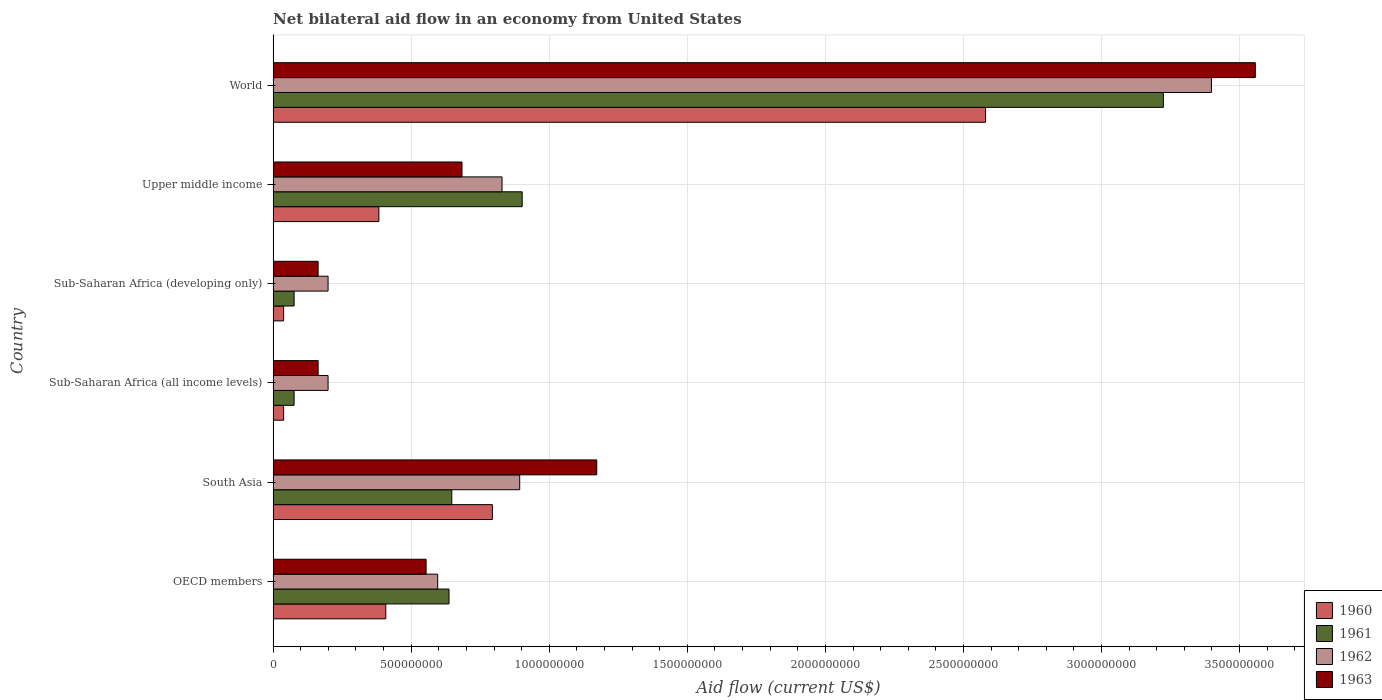How many different coloured bars are there?
Your answer should be compact. 4. How many groups of bars are there?
Provide a succinct answer. 6. Are the number of bars per tick equal to the number of legend labels?
Make the answer very short. Yes. How many bars are there on the 5th tick from the top?
Keep it short and to the point. 4. What is the label of the 5th group of bars from the top?
Your answer should be very brief. South Asia. In how many cases, is the number of bars for a given country not equal to the number of legend labels?
Give a very brief answer. 0. What is the net bilateral aid flow in 1961 in South Asia?
Your response must be concise. 6.47e+08. Across all countries, what is the maximum net bilateral aid flow in 1961?
Give a very brief answer. 3.22e+09. Across all countries, what is the minimum net bilateral aid flow in 1960?
Ensure brevity in your answer.  3.80e+07. In which country was the net bilateral aid flow in 1960 maximum?
Your answer should be very brief. World. In which country was the net bilateral aid flow in 1961 minimum?
Provide a short and direct response. Sub-Saharan Africa (all income levels). What is the total net bilateral aid flow in 1960 in the graph?
Give a very brief answer. 4.24e+09. What is the difference between the net bilateral aid flow in 1960 in OECD members and that in Upper middle income?
Your answer should be compact. 2.50e+07. What is the difference between the net bilateral aid flow in 1961 in World and the net bilateral aid flow in 1960 in Upper middle income?
Your response must be concise. 2.84e+09. What is the average net bilateral aid flow in 1963 per country?
Offer a very short reply. 1.05e+09. What is the difference between the net bilateral aid flow in 1962 and net bilateral aid flow in 1960 in Sub-Saharan Africa (developing only)?
Give a very brief answer. 1.61e+08. In how many countries, is the net bilateral aid flow in 1962 greater than 1500000000 US$?
Offer a terse response. 1. What is the ratio of the net bilateral aid flow in 1961 in South Asia to that in Sub-Saharan Africa (all income levels)?
Provide a short and direct response. 8.51. Is the net bilateral aid flow in 1961 in South Asia less than that in Sub-Saharan Africa (all income levels)?
Offer a very short reply. No. Is the difference between the net bilateral aid flow in 1962 in South Asia and Upper middle income greater than the difference between the net bilateral aid flow in 1960 in South Asia and Upper middle income?
Make the answer very short. No. What is the difference between the highest and the second highest net bilateral aid flow in 1962?
Ensure brevity in your answer.  2.50e+09. What is the difference between the highest and the lowest net bilateral aid flow in 1960?
Make the answer very short. 2.54e+09. In how many countries, is the net bilateral aid flow in 1962 greater than the average net bilateral aid flow in 1962 taken over all countries?
Give a very brief answer. 1. Is the sum of the net bilateral aid flow in 1960 in South Asia and Sub-Saharan Africa (developing only) greater than the maximum net bilateral aid flow in 1962 across all countries?
Offer a very short reply. No. Is it the case that in every country, the sum of the net bilateral aid flow in 1963 and net bilateral aid flow in 1962 is greater than the net bilateral aid flow in 1961?
Provide a succinct answer. Yes. How many bars are there?
Your answer should be very brief. 24. Are all the bars in the graph horizontal?
Your response must be concise. Yes. Are the values on the major ticks of X-axis written in scientific E-notation?
Provide a short and direct response. No. Where does the legend appear in the graph?
Provide a short and direct response. Bottom right. How many legend labels are there?
Keep it short and to the point. 4. How are the legend labels stacked?
Give a very brief answer. Vertical. What is the title of the graph?
Ensure brevity in your answer.  Net bilateral aid flow in an economy from United States. Does "1996" appear as one of the legend labels in the graph?
Make the answer very short. No. What is the label or title of the Y-axis?
Make the answer very short. Country. What is the Aid flow (current US$) of 1960 in OECD members?
Your response must be concise. 4.08e+08. What is the Aid flow (current US$) of 1961 in OECD members?
Provide a short and direct response. 6.37e+08. What is the Aid flow (current US$) in 1962 in OECD members?
Offer a very short reply. 5.96e+08. What is the Aid flow (current US$) of 1963 in OECD members?
Ensure brevity in your answer.  5.54e+08. What is the Aid flow (current US$) in 1960 in South Asia?
Give a very brief answer. 7.94e+08. What is the Aid flow (current US$) in 1961 in South Asia?
Your answer should be very brief. 6.47e+08. What is the Aid flow (current US$) in 1962 in South Asia?
Give a very brief answer. 8.93e+08. What is the Aid flow (current US$) in 1963 in South Asia?
Provide a succinct answer. 1.17e+09. What is the Aid flow (current US$) in 1960 in Sub-Saharan Africa (all income levels)?
Give a very brief answer. 3.80e+07. What is the Aid flow (current US$) in 1961 in Sub-Saharan Africa (all income levels)?
Offer a very short reply. 7.60e+07. What is the Aid flow (current US$) of 1962 in Sub-Saharan Africa (all income levels)?
Your answer should be compact. 1.99e+08. What is the Aid flow (current US$) of 1963 in Sub-Saharan Africa (all income levels)?
Give a very brief answer. 1.63e+08. What is the Aid flow (current US$) in 1960 in Sub-Saharan Africa (developing only)?
Provide a succinct answer. 3.80e+07. What is the Aid flow (current US$) of 1961 in Sub-Saharan Africa (developing only)?
Make the answer very short. 7.60e+07. What is the Aid flow (current US$) of 1962 in Sub-Saharan Africa (developing only)?
Offer a terse response. 1.99e+08. What is the Aid flow (current US$) in 1963 in Sub-Saharan Africa (developing only)?
Make the answer very short. 1.63e+08. What is the Aid flow (current US$) in 1960 in Upper middle income?
Keep it short and to the point. 3.83e+08. What is the Aid flow (current US$) in 1961 in Upper middle income?
Your response must be concise. 9.02e+08. What is the Aid flow (current US$) in 1962 in Upper middle income?
Your answer should be compact. 8.29e+08. What is the Aid flow (current US$) in 1963 in Upper middle income?
Your response must be concise. 6.84e+08. What is the Aid flow (current US$) in 1960 in World?
Ensure brevity in your answer.  2.58e+09. What is the Aid flow (current US$) of 1961 in World?
Make the answer very short. 3.22e+09. What is the Aid flow (current US$) of 1962 in World?
Your answer should be compact. 3.40e+09. What is the Aid flow (current US$) of 1963 in World?
Your answer should be compact. 3.56e+09. Across all countries, what is the maximum Aid flow (current US$) in 1960?
Keep it short and to the point. 2.58e+09. Across all countries, what is the maximum Aid flow (current US$) of 1961?
Provide a short and direct response. 3.22e+09. Across all countries, what is the maximum Aid flow (current US$) of 1962?
Ensure brevity in your answer.  3.40e+09. Across all countries, what is the maximum Aid flow (current US$) in 1963?
Your answer should be compact. 3.56e+09. Across all countries, what is the minimum Aid flow (current US$) of 1960?
Provide a short and direct response. 3.80e+07. Across all countries, what is the minimum Aid flow (current US$) of 1961?
Keep it short and to the point. 7.60e+07. Across all countries, what is the minimum Aid flow (current US$) in 1962?
Your answer should be compact. 1.99e+08. Across all countries, what is the minimum Aid flow (current US$) in 1963?
Offer a terse response. 1.63e+08. What is the total Aid flow (current US$) in 1960 in the graph?
Offer a terse response. 4.24e+09. What is the total Aid flow (current US$) in 1961 in the graph?
Offer a terse response. 5.56e+09. What is the total Aid flow (current US$) of 1962 in the graph?
Give a very brief answer. 6.11e+09. What is the total Aid flow (current US$) of 1963 in the graph?
Provide a short and direct response. 6.29e+09. What is the difference between the Aid flow (current US$) of 1960 in OECD members and that in South Asia?
Ensure brevity in your answer.  -3.86e+08. What is the difference between the Aid flow (current US$) of 1961 in OECD members and that in South Asia?
Offer a terse response. -1.00e+07. What is the difference between the Aid flow (current US$) in 1962 in OECD members and that in South Asia?
Offer a terse response. -2.97e+08. What is the difference between the Aid flow (current US$) of 1963 in OECD members and that in South Asia?
Keep it short and to the point. -6.18e+08. What is the difference between the Aid flow (current US$) in 1960 in OECD members and that in Sub-Saharan Africa (all income levels)?
Make the answer very short. 3.70e+08. What is the difference between the Aid flow (current US$) in 1961 in OECD members and that in Sub-Saharan Africa (all income levels)?
Ensure brevity in your answer.  5.61e+08. What is the difference between the Aid flow (current US$) in 1962 in OECD members and that in Sub-Saharan Africa (all income levels)?
Ensure brevity in your answer.  3.97e+08. What is the difference between the Aid flow (current US$) in 1963 in OECD members and that in Sub-Saharan Africa (all income levels)?
Your answer should be compact. 3.91e+08. What is the difference between the Aid flow (current US$) in 1960 in OECD members and that in Sub-Saharan Africa (developing only)?
Your response must be concise. 3.70e+08. What is the difference between the Aid flow (current US$) of 1961 in OECD members and that in Sub-Saharan Africa (developing only)?
Your answer should be very brief. 5.61e+08. What is the difference between the Aid flow (current US$) of 1962 in OECD members and that in Sub-Saharan Africa (developing only)?
Offer a very short reply. 3.97e+08. What is the difference between the Aid flow (current US$) of 1963 in OECD members and that in Sub-Saharan Africa (developing only)?
Make the answer very short. 3.91e+08. What is the difference between the Aid flow (current US$) in 1960 in OECD members and that in Upper middle income?
Your response must be concise. 2.50e+07. What is the difference between the Aid flow (current US$) of 1961 in OECD members and that in Upper middle income?
Your answer should be very brief. -2.65e+08. What is the difference between the Aid flow (current US$) of 1962 in OECD members and that in Upper middle income?
Your response must be concise. -2.33e+08. What is the difference between the Aid flow (current US$) of 1963 in OECD members and that in Upper middle income?
Your response must be concise. -1.30e+08. What is the difference between the Aid flow (current US$) of 1960 in OECD members and that in World?
Make the answer very short. -2.17e+09. What is the difference between the Aid flow (current US$) of 1961 in OECD members and that in World?
Keep it short and to the point. -2.59e+09. What is the difference between the Aid flow (current US$) of 1962 in OECD members and that in World?
Provide a short and direct response. -2.80e+09. What is the difference between the Aid flow (current US$) of 1963 in OECD members and that in World?
Keep it short and to the point. -3.00e+09. What is the difference between the Aid flow (current US$) in 1960 in South Asia and that in Sub-Saharan Africa (all income levels)?
Provide a short and direct response. 7.56e+08. What is the difference between the Aid flow (current US$) in 1961 in South Asia and that in Sub-Saharan Africa (all income levels)?
Make the answer very short. 5.71e+08. What is the difference between the Aid flow (current US$) in 1962 in South Asia and that in Sub-Saharan Africa (all income levels)?
Give a very brief answer. 6.94e+08. What is the difference between the Aid flow (current US$) in 1963 in South Asia and that in Sub-Saharan Africa (all income levels)?
Your response must be concise. 1.01e+09. What is the difference between the Aid flow (current US$) in 1960 in South Asia and that in Sub-Saharan Africa (developing only)?
Your response must be concise. 7.56e+08. What is the difference between the Aid flow (current US$) of 1961 in South Asia and that in Sub-Saharan Africa (developing only)?
Your answer should be compact. 5.71e+08. What is the difference between the Aid flow (current US$) in 1962 in South Asia and that in Sub-Saharan Africa (developing only)?
Give a very brief answer. 6.94e+08. What is the difference between the Aid flow (current US$) of 1963 in South Asia and that in Sub-Saharan Africa (developing only)?
Your response must be concise. 1.01e+09. What is the difference between the Aid flow (current US$) in 1960 in South Asia and that in Upper middle income?
Make the answer very short. 4.11e+08. What is the difference between the Aid flow (current US$) in 1961 in South Asia and that in Upper middle income?
Provide a succinct answer. -2.55e+08. What is the difference between the Aid flow (current US$) of 1962 in South Asia and that in Upper middle income?
Your answer should be very brief. 6.40e+07. What is the difference between the Aid flow (current US$) of 1963 in South Asia and that in Upper middle income?
Provide a succinct answer. 4.88e+08. What is the difference between the Aid flow (current US$) in 1960 in South Asia and that in World?
Your answer should be very brief. -1.79e+09. What is the difference between the Aid flow (current US$) in 1961 in South Asia and that in World?
Your answer should be very brief. -2.58e+09. What is the difference between the Aid flow (current US$) of 1962 in South Asia and that in World?
Ensure brevity in your answer.  -2.50e+09. What is the difference between the Aid flow (current US$) of 1963 in South Asia and that in World?
Your answer should be very brief. -2.38e+09. What is the difference between the Aid flow (current US$) in 1960 in Sub-Saharan Africa (all income levels) and that in Sub-Saharan Africa (developing only)?
Your answer should be compact. 0. What is the difference between the Aid flow (current US$) of 1962 in Sub-Saharan Africa (all income levels) and that in Sub-Saharan Africa (developing only)?
Provide a short and direct response. 0. What is the difference between the Aid flow (current US$) of 1960 in Sub-Saharan Africa (all income levels) and that in Upper middle income?
Make the answer very short. -3.45e+08. What is the difference between the Aid flow (current US$) in 1961 in Sub-Saharan Africa (all income levels) and that in Upper middle income?
Make the answer very short. -8.26e+08. What is the difference between the Aid flow (current US$) in 1962 in Sub-Saharan Africa (all income levels) and that in Upper middle income?
Your answer should be compact. -6.30e+08. What is the difference between the Aid flow (current US$) in 1963 in Sub-Saharan Africa (all income levels) and that in Upper middle income?
Your answer should be very brief. -5.21e+08. What is the difference between the Aid flow (current US$) of 1960 in Sub-Saharan Africa (all income levels) and that in World?
Give a very brief answer. -2.54e+09. What is the difference between the Aid flow (current US$) in 1961 in Sub-Saharan Africa (all income levels) and that in World?
Give a very brief answer. -3.15e+09. What is the difference between the Aid flow (current US$) in 1962 in Sub-Saharan Africa (all income levels) and that in World?
Keep it short and to the point. -3.20e+09. What is the difference between the Aid flow (current US$) in 1963 in Sub-Saharan Africa (all income levels) and that in World?
Offer a terse response. -3.39e+09. What is the difference between the Aid flow (current US$) of 1960 in Sub-Saharan Africa (developing only) and that in Upper middle income?
Ensure brevity in your answer.  -3.45e+08. What is the difference between the Aid flow (current US$) in 1961 in Sub-Saharan Africa (developing only) and that in Upper middle income?
Your answer should be very brief. -8.26e+08. What is the difference between the Aid flow (current US$) of 1962 in Sub-Saharan Africa (developing only) and that in Upper middle income?
Your response must be concise. -6.30e+08. What is the difference between the Aid flow (current US$) in 1963 in Sub-Saharan Africa (developing only) and that in Upper middle income?
Offer a very short reply. -5.21e+08. What is the difference between the Aid flow (current US$) of 1960 in Sub-Saharan Africa (developing only) and that in World?
Keep it short and to the point. -2.54e+09. What is the difference between the Aid flow (current US$) in 1961 in Sub-Saharan Africa (developing only) and that in World?
Offer a very short reply. -3.15e+09. What is the difference between the Aid flow (current US$) in 1962 in Sub-Saharan Africa (developing only) and that in World?
Ensure brevity in your answer.  -3.20e+09. What is the difference between the Aid flow (current US$) in 1963 in Sub-Saharan Africa (developing only) and that in World?
Give a very brief answer. -3.39e+09. What is the difference between the Aid flow (current US$) of 1960 in Upper middle income and that in World?
Offer a very short reply. -2.20e+09. What is the difference between the Aid flow (current US$) of 1961 in Upper middle income and that in World?
Make the answer very short. -2.32e+09. What is the difference between the Aid flow (current US$) in 1962 in Upper middle income and that in World?
Provide a succinct answer. -2.57e+09. What is the difference between the Aid flow (current US$) of 1963 in Upper middle income and that in World?
Your answer should be very brief. -2.87e+09. What is the difference between the Aid flow (current US$) of 1960 in OECD members and the Aid flow (current US$) of 1961 in South Asia?
Offer a terse response. -2.39e+08. What is the difference between the Aid flow (current US$) in 1960 in OECD members and the Aid flow (current US$) in 1962 in South Asia?
Give a very brief answer. -4.85e+08. What is the difference between the Aid flow (current US$) of 1960 in OECD members and the Aid flow (current US$) of 1963 in South Asia?
Keep it short and to the point. -7.64e+08. What is the difference between the Aid flow (current US$) in 1961 in OECD members and the Aid flow (current US$) in 1962 in South Asia?
Your answer should be compact. -2.56e+08. What is the difference between the Aid flow (current US$) in 1961 in OECD members and the Aid flow (current US$) in 1963 in South Asia?
Your response must be concise. -5.35e+08. What is the difference between the Aid flow (current US$) in 1962 in OECD members and the Aid flow (current US$) in 1963 in South Asia?
Provide a succinct answer. -5.76e+08. What is the difference between the Aid flow (current US$) in 1960 in OECD members and the Aid flow (current US$) in 1961 in Sub-Saharan Africa (all income levels)?
Make the answer very short. 3.32e+08. What is the difference between the Aid flow (current US$) in 1960 in OECD members and the Aid flow (current US$) in 1962 in Sub-Saharan Africa (all income levels)?
Your answer should be very brief. 2.09e+08. What is the difference between the Aid flow (current US$) in 1960 in OECD members and the Aid flow (current US$) in 1963 in Sub-Saharan Africa (all income levels)?
Your answer should be very brief. 2.45e+08. What is the difference between the Aid flow (current US$) of 1961 in OECD members and the Aid flow (current US$) of 1962 in Sub-Saharan Africa (all income levels)?
Offer a terse response. 4.38e+08. What is the difference between the Aid flow (current US$) of 1961 in OECD members and the Aid flow (current US$) of 1963 in Sub-Saharan Africa (all income levels)?
Make the answer very short. 4.74e+08. What is the difference between the Aid flow (current US$) of 1962 in OECD members and the Aid flow (current US$) of 1963 in Sub-Saharan Africa (all income levels)?
Your answer should be very brief. 4.33e+08. What is the difference between the Aid flow (current US$) in 1960 in OECD members and the Aid flow (current US$) in 1961 in Sub-Saharan Africa (developing only)?
Your answer should be very brief. 3.32e+08. What is the difference between the Aid flow (current US$) of 1960 in OECD members and the Aid flow (current US$) of 1962 in Sub-Saharan Africa (developing only)?
Provide a short and direct response. 2.09e+08. What is the difference between the Aid flow (current US$) in 1960 in OECD members and the Aid flow (current US$) in 1963 in Sub-Saharan Africa (developing only)?
Offer a very short reply. 2.45e+08. What is the difference between the Aid flow (current US$) of 1961 in OECD members and the Aid flow (current US$) of 1962 in Sub-Saharan Africa (developing only)?
Give a very brief answer. 4.38e+08. What is the difference between the Aid flow (current US$) of 1961 in OECD members and the Aid flow (current US$) of 1963 in Sub-Saharan Africa (developing only)?
Your answer should be very brief. 4.74e+08. What is the difference between the Aid flow (current US$) in 1962 in OECD members and the Aid flow (current US$) in 1963 in Sub-Saharan Africa (developing only)?
Your answer should be compact. 4.33e+08. What is the difference between the Aid flow (current US$) in 1960 in OECD members and the Aid flow (current US$) in 1961 in Upper middle income?
Keep it short and to the point. -4.94e+08. What is the difference between the Aid flow (current US$) of 1960 in OECD members and the Aid flow (current US$) of 1962 in Upper middle income?
Your answer should be compact. -4.21e+08. What is the difference between the Aid flow (current US$) in 1960 in OECD members and the Aid flow (current US$) in 1963 in Upper middle income?
Offer a very short reply. -2.76e+08. What is the difference between the Aid flow (current US$) of 1961 in OECD members and the Aid flow (current US$) of 1962 in Upper middle income?
Offer a very short reply. -1.92e+08. What is the difference between the Aid flow (current US$) in 1961 in OECD members and the Aid flow (current US$) in 1963 in Upper middle income?
Keep it short and to the point. -4.70e+07. What is the difference between the Aid flow (current US$) in 1962 in OECD members and the Aid flow (current US$) in 1963 in Upper middle income?
Keep it short and to the point. -8.80e+07. What is the difference between the Aid flow (current US$) of 1960 in OECD members and the Aid flow (current US$) of 1961 in World?
Your response must be concise. -2.82e+09. What is the difference between the Aid flow (current US$) in 1960 in OECD members and the Aid flow (current US$) in 1962 in World?
Your answer should be very brief. -2.99e+09. What is the difference between the Aid flow (current US$) of 1960 in OECD members and the Aid flow (current US$) of 1963 in World?
Make the answer very short. -3.15e+09. What is the difference between the Aid flow (current US$) of 1961 in OECD members and the Aid flow (current US$) of 1962 in World?
Make the answer very short. -2.76e+09. What is the difference between the Aid flow (current US$) of 1961 in OECD members and the Aid flow (current US$) of 1963 in World?
Ensure brevity in your answer.  -2.92e+09. What is the difference between the Aid flow (current US$) in 1962 in OECD members and the Aid flow (current US$) in 1963 in World?
Offer a terse response. -2.96e+09. What is the difference between the Aid flow (current US$) of 1960 in South Asia and the Aid flow (current US$) of 1961 in Sub-Saharan Africa (all income levels)?
Make the answer very short. 7.18e+08. What is the difference between the Aid flow (current US$) of 1960 in South Asia and the Aid flow (current US$) of 1962 in Sub-Saharan Africa (all income levels)?
Offer a terse response. 5.95e+08. What is the difference between the Aid flow (current US$) in 1960 in South Asia and the Aid flow (current US$) in 1963 in Sub-Saharan Africa (all income levels)?
Provide a succinct answer. 6.31e+08. What is the difference between the Aid flow (current US$) in 1961 in South Asia and the Aid flow (current US$) in 1962 in Sub-Saharan Africa (all income levels)?
Give a very brief answer. 4.48e+08. What is the difference between the Aid flow (current US$) in 1961 in South Asia and the Aid flow (current US$) in 1963 in Sub-Saharan Africa (all income levels)?
Your answer should be compact. 4.84e+08. What is the difference between the Aid flow (current US$) of 1962 in South Asia and the Aid flow (current US$) of 1963 in Sub-Saharan Africa (all income levels)?
Ensure brevity in your answer.  7.30e+08. What is the difference between the Aid flow (current US$) of 1960 in South Asia and the Aid flow (current US$) of 1961 in Sub-Saharan Africa (developing only)?
Provide a succinct answer. 7.18e+08. What is the difference between the Aid flow (current US$) of 1960 in South Asia and the Aid flow (current US$) of 1962 in Sub-Saharan Africa (developing only)?
Ensure brevity in your answer.  5.95e+08. What is the difference between the Aid flow (current US$) of 1960 in South Asia and the Aid flow (current US$) of 1963 in Sub-Saharan Africa (developing only)?
Give a very brief answer. 6.31e+08. What is the difference between the Aid flow (current US$) of 1961 in South Asia and the Aid flow (current US$) of 1962 in Sub-Saharan Africa (developing only)?
Offer a terse response. 4.48e+08. What is the difference between the Aid flow (current US$) in 1961 in South Asia and the Aid flow (current US$) in 1963 in Sub-Saharan Africa (developing only)?
Give a very brief answer. 4.84e+08. What is the difference between the Aid flow (current US$) in 1962 in South Asia and the Aid flow (current US$) in 1963 in Sub-Saharan Africa (developing only)?
Provide a short and direct response. 7.30e+08. What is the difference between the Aid flow (current US$) in 1960 in South Asia and the Aid flow (current US$) in 1961 in Upper middle income?
Your response must be concise. -1.08e+08. What is the difference between the Aid flow (current US$) in 1960 in South Asia and the Aid flow (current US$) in 1962 in Upper middle income?
Your answer should be compact. -3.50e+07. What is the difference between the Aid flow (current US$) of 1960 in South Asia and the Aid flow (current US$) of 1963 in Upper middle income?
Your response must be concise. 1.10e+08. What is the difference between the Aid flow (current US$) of 1961 in South Asia and the Aid flow (current US$) of 1962 in Upper middle income?
Your response must be concise. -1.82e+08. What is the difference between the Aid flow (current US$) of 1961 in South Asia and the Aid flow (current US$) of 1963 in Upper middle income?
Offer a very short reply. -3.70e+07. What is the difference between the Aid flow (current US$) of 1962 in South Asia and the Aid flow (current US$) of 1963 in Upper middle income?
Keep it short and to the point. 2.09e+08. What is the difference between the Aid flow (current US$) in 1960 in South Asia and the Aid flow (current US$) in 1961 in World?
Provide a succinct answer. -2.43e+09. What is the difference between the Aid flow (current US$) in 1960 in South Asia and the Aid flow (current US$) in 1962 in World?
Your answer should be very brief. -2.60e+09. What is the difference between the Aid flow (current US$) of 1960 in South Asia and the Aid flow (current US$) of 1963 in World?
Offer a very short reply. -2.76e+09. What is the difference between the Aid flow (current US$) of 1961 in South Asia and the Aid flow (current US$) of 1962 in World?
Your response must be concise. -2.75e+09. What is the difference between the Aid flow (current US$) in 1961 in South Asia and the Aid flow (current US$) in 1963 in World?
Provide a short and direct response. -2.91e+09. What is the difference between the Aid flow (current US$) in 1962 in South Asia and the Aid flow (current US$) in 1963 in World?
Make the answer very short. -2.66e+09. What is the difference between the Aid flow (current US$) of 1960 in Sub-Saharan Africa (all income levels) and the Aid flow (current US$) of 1961 in Sub-Saharan Africa (developing only)?
Offer a terse response. -3.80e+07. What is the difference between the Aid flow (current US$) of 1960 in Sub-Saharan Africa (all income levels) and the Aid flow (current US$) of 1962 in Sub-Saharan Africa (developing only)?
Offer a terse response. -1.61e+08. What is the difference between the Aid flow (current US$) in 1960 in Sub-Saharan Africa (all income levels) and the Aid flow (current US$) in 1963 in Sub-Saharan Africa (developing only)?
Your answer should be very brief. -1.25e+08. What is the difference between the Aid flow (current US$) in 1961 in Sub-Saharan Africa (all income levels) and the Aid flow (current US$) in 1962 in Sub-Saharan Africa (developing only)?
Give a very brief answer. -1.23e+08. What is the difference between the Aid flow (current US$) in 1961 in Sub-Saharan Africa (all income levels) and the Aid flow (current US$) in 1963 in Sub-Saharan Africa (developing only)?
Provide a succinct answer. -8.70e+07. What is the difference between the Aid flow (current US$) in 1962 in Sub-Saharan Africa (all income levels) and the Aid flow (current US$) in 1963 in Sub-Saharan Africa (developing only)?
Offer a terse response. 3.60e+07. What is the difference between the Aid flow (current US$) of 1960 in Sub-Saharan Africa (all income levels) and the Aid flow (current US$) of 1961 in Upper middle income?
Ensure brevity in your answer.  -8.64e+08. What is the difference between the Aid flow (current US$) in 1960 in Sub-Saharan Africa (all income levels) and the Aid flow (current US$) in 1962 in Upper middle income?
Give a very brief answer. -7.91e+08. What is the difference between the Aid flow (current US$) of 1960 in Sub-Saharan Africa (all income levels) and the Aid flow (current US$) of 1963 in Upper middle income?
Ensure brevity in your answer.  -6.46e+08. What is the difference between the Aid flow (current US$) of 1961 in Sub-Saharan Africa (all income levels) and the Aid flow (current US$) of 1962 in Upper middle income?
Your response must be concise. -7.53e+08. What is the difference between the Aid flow (current US$) in 1961 in Sub-Saharan Africa (all income levels) and the Aid flow (current US$) in 1963 in Upper middle income?
Your response must be concise. -6.08e+08. What is the difference between the Aid flow (current US$) in 1962 in Sub-Saharan Africa (all income levels) and the Aid flow (current US$) in 1963 in Upper middle income?
Offer a terse response. -4.85e+08. What is the difference between the Aid flow (current US$) of 1960 in Sub-Saharan Africa (all income levels) and the Aid flow (current US$) of 1961 in World?
Ensure brevity in your answer.  -3.19e+09. What is the difference between the Aid flow (current US$) of 1960 in Sub-Saharan Africa (all income levels) and the Aid flow (current US$) of 1962 in World?
Provide a succinct answer. -3.36e+09. What is the difference between the Aid flow (current US$) in 1960 in Sub-Saharan Africa (all income levels) and the Aid flow (current US$) in 1963 in World?
Ensure brevity in your answer.  -3.52e+09. What is the difference between the Aid flow (current US$) in 1961 in Sub-Saharan Africa (all income levels) and the Aid flow (current US$) in 1962 in World?
Offer a terse response. -3.32e+09. What is the difference between the Aid flow (current US$) of 1961 in Sub-Saharan Africa (all income levels) and the Aid flow (current US$) of 1963 in World?
Provide a succinct answer. -3.48e+09. What is the difference between the Aid flow (current US$) in 1962 in Sub-Saharan Africa (all income levels) and the Aid flow (current US$) in 1963 in World?
Provide a short and direct response. -3.36e+09. What is the difference between the Aid flow (current US$) in 1960 in Sub-Saharan Africa (developing only) and the Aid flow (current US$) in 1961 in Upper middle income?
Provide a succinct answer. -8.64e+08. What is the difference between the Aid flow (current US$) of 1960 in Sub-Saharan Africa (developing only) and the Aid flow (current US$) of 1962 in Upper middle income?
Offer a terse response. -7.91e+08. What is the difference between the Aid flow (current US$) of 1960 in Sub-Saharan Africa (developing only) and the Aid flow (current US$) of 1963 in Upper middle income?
Provide a short and direct response. -6.46e+08. What is the difference between the Aid flow (current US$) in 1961 in Sub-Saharan Africa (developing only) and the Aid flow (current US$) in 1962 in Upper middle income?
Offer a terse response. -7.53e+08. What is the difference between the Aid flow (current US$) in 1961 in Sub-Saharan Africa (developing only) and the Aid flow (current US$) in 1963 in Upper middle income?
Give a very brief answer. -6.08e+08. What is the difference between the Aid flow (current US$) of 1962 in Sub-Saharan Africa (developing only) and the Aid flow (current US$) of 1963 in Upper middle income?
Offer a terse response. -4.85e+08. What is the difference between the Aid flow (current US$) in 1960 in Sub-Saharan Africa (developing only) and the Aid flow (current US$) in 1961 in World?
Make the answer very short. -3.19e+09. What is the difference between the Aid flow (current US$) of 1960 in Sub-Saharan Africa (developing only) and the Aid flow (current US$) of 1962 in World?
Provide a short and direct response. -3.36e+09. What is the difference between the Aid flow (current US$) of 1960 in Sub-Saharan Africa (developing only) and the Aid flow (current US$) of 1963 in World?
Your answer should be very brief. -3.52e+09. What is the difference between the Aid flow (current US$) of 1961 in Sub-Saharan Africa (developing only) and the Aid flow (current US$) of 1962 in World?
Ensure brevity in your answer.  -3.32e+09. What is the difference between the Aid flow (current US$) of 1961 in Sub-Saharan Africa (developing only) and the Aid flow (current US$) of 1963 in World?
Your response must be concise. -3.48e+09. What is the difference between the Aid flow (current US$) in 1962 in Sub-Saharan Africa (developing only) and the Aid flow (current US$) in 1963 in World?
Your answer should be compact. -3.36e+09. What is the difference between the Aid flow (current US$) of 1960 in Upper middle income and the Aid flow (current US$) of 1961 in World?
Offer a terse response. -2.84e+09. What is the difference between the Aid flow (current US$) of 1960 in Upper middle income and the Aid flow (current US$) of 1962 in World?
Provide a succinct answer. -3.02e+09. What is the difference between the Aid flow (current US$) in 1960 in Upper middle income and the Aid flow (current US$) in 1963 in World?
Your answer should be very brief. -3.17e+09. What is the difference between the Aid flow (current US$) in 1961 in Upper middle income and the Aid flow (current US$) in 1962 in World?
Provide a succinct answer. -2.50e+09. What is the difference between the Aid flow (current US$) in 1961 in Upper middle income and the Aid flow (current US$) in 1963 in World?
Offer a terse response. -2.66e+09. What is the difference between the Aid flow (current US$) of 1962 in Upper middle income and the Aid flow (current US$) of 1963 in World?
Your answer should be compact. -2.73e+09. What is the average Aid flow (current US$) in 1960 per country?
Keep it short and to the point. 7.07e+08. What is the average Aid flow (current US$) of 1961 per country?
Provide a succinct answer. 9.27e+08. What is the average Aid flow (current US$) of 1962 per country?
Your response must be concise. 1.02e+09. What is the average Aid flow (current US$) in 1963 per country?
Provide a short and direct response. 1.05e+09. What is the difference between the Aid flow (current US$) in 1960 and Aid flow (current US$) in 1961 in OECD members?
Your answer should be compact. -2.29e+08. What is the difference between the Aid flow (current US$) of 1960 and Aid flow (current US$) of 1962 in OECD members?
Your response must be concise. -1.88e+08. What is the difference between the Aid flow (current US$) in 1960 and Aid flow (current US$) in 1963 in OECD members?
Your answer should be compact. -1.46e+08. What is the difference between the Aid flow (current US$) of 1961 and Aid flow (current US$) of 1962 in OECD members?
Provide a short and direct response. 4.10e+07. What is the difference between the Aid flow (current US$) of 1961 and Aid flow (current US$) of 1963 in OECD members?
Offer a very short reply. 8.30e+07. What is the difference between the Aid flow (current US$) in 1962 and Aid flow (current US$) in 1963 in OECD members?
Offer a terse response. 4.20e+07. What is the difference between the Aid flow (current US$) in 1960 and Aid flow (current US$) in 1961 in South Asia?
Offer a very short reply. 1.47e+08. What is the difference between the Aid flow (current US$) in 1960 and Aid flow (current US$) in 1962 in South Asia?
Ensure brevity in your answer.  -9.90e+07. What is the difference between the Aid flow (current US$) in 1960 and Aid flow (current US$) in 1963 in South Asia?
Give a very brief answer. -3.78e+08. What is the difference between the Aid flow (current US$) of 1961 and Aid flow (current US$) of 1962 in South Asia?
Make the answer very short. -2.46e+08. What is the difference between the Aid flow (current US$) in 1961 and Aid flow (current US$) in 1963 in South Asia?
Keep it short and to the point. -5.25e+08. What is the difference between the Aid flow (current US$) of 1962 and Aid flow (current US$) of 1963 in South Asia?
Your response must be concise. -2.79e+08. What is the difference between the Aid flow (current US$) of 1960 and Aid flow (current US$) of 1961 in Sub-Saharan Africa (all income levels)?
Offer a terse response. -3.80e+07. What is the difference between the Aid flow (current US$) in 1960 and Aid flow (current US$) in 1962 in Sub-Saharan Africa (all income levels)?
Offer a terse response. -1.61e+08. What is the difference between the Aid flow (current US$) of 1960 and Aid flow (current US$) of 1963 in Sub-Saharan Africa (all income levels)?
Offer a very short reply. -1.25e+08. What is the difference between the Aid flow (current US$) of 1961 and Aid flow (current US$) of 1962 in Sub-Saharan Africa (all income levels)?
Provide a succinct answer. -1.23e+08. What is the difference between the Aid flow (current US$) of 1961 and Aid flow (current US$) of 1963 in Sub-Saharan Africa (all income levels)?
Make the answer very short. -8.70e+07. What is the difference between the Aid flow (current US$) in 1962 and Aid flow (current US$) in 1963 in Sub-Saharan Africa (all income levels)?
Your answer should be very brief. 3.60e+07. What is the difference between the Aid flow (current US$) in 1960 and Aid flow (current US$) in 1961 in Sub-Saharan Africa (developing only)?
Make the answer very short. -3.80e+07. What is the difference between the Aid flow (current US$) of 1960 and Aid flow (current US$) of 1962 in Sub-Saharan Africa (developing only)?
Provide a short and direct response. -1.61e+08. What is the difference between the Aid flow (current US$) of 1960 and Aid flow (current US$) of 1963 in Sub-Saharan Africa (developing only)?
Provide a succinct answer. -1.25e+08. What is the difference between the Aid flow (current US$) of 1961 and Aid flow (current US$) of 1962 in Sub-Saharan Africa (developing only)?
Give a very brief answer. -1.23e+08. What is the difference between the Aid flow (current US$) of 1961 and Aid flow (current US$) of 1963 in Sub-Saharan Africa (developing only)?
Your answer should be very brief. -8.70e+07. What is the difference between the Aid flow (current US$) of 1962 and Aid flow (current US$) of 1963 in Sub-Saharan Africa (developing only)?
Your response must be concise. 3.60e+07. What is the difference between the Aid flow (current US$) in 1960 and Aid flow (current US$) in 1961 in Upper middle income?
Your response must be concise. -5.19e+08. What is the difference between the Aid flow (current US$) in 1960 and Aid flow (current US$) in 1962 in Upper middle income?
Your answer should be very brief. -4.46e+08. What is the difference between the Aid flow (current US$) in 1960 and Aid flow (current US$) in 1963 in Upper middle income?
Provide a succinct answer. -3.01e+08. What is the difference between the Aid flow (current US$) in 1961 and Aid flow (current US$) in 1962 in Upper middle income?
Offer a very short reply. 7.30e+07. What is the difference between the Aid flow (current US$) in 1961 and Aid flow (current US$) in 1963 in Upper middle income?
Your response must be concise. 2.18e+08. What is the difference between the Aid flow (current US$) of 1962 and Aid flow (current US$) of 1963 in Upper middle income?
Ensure brevity in your answer.  1.45e+08. What is the difference between the Aid flow (current US$) in 1960 and Aid flow (current US$) in 1961 in World?
Your answer should be very brief. -6.44e+08. What is the difference between the Aid flow (current US$) of 1960 and Aid flow (current US$) of 1962 in World?
Keep it short and to the point. -8.18e+08. What is the difference between the Aid flow (current US$) of 1960 and Aid flow (current US$) of 1963 in World?
Ensure brevity in your answer.  -9.77e+08. What is the difference between the Aid flow (current US$) of 1961 and Aid flow (current US$) of 1962 in World?
Ensure brevity in your answer.  -1.74e+08. What is the difference between the Aid flow (current US$) of 1961 and Aid flow (current US$) of 1963 in World?
Give a very brief answer. -3.33e+08. What is the difference between the Aid flow (current US$) in 1962 and Aid flow (current US$) in 1963 in World?
Your answer should be very brief. -1.59e+08. What is the ratio of the Aid flow (current US$) of 1960 in OECD members to that in South Asia?
Offer a very short reply. 0.51. What is the ratio of the Aid flow (current US$) of 1961 in OECD members to that in South Asia?
Keep it short and to the point. 0.98. What is the ratio of the Aid flow (current US$) of 1962 in OECD members to that in South Asia?
Provide a short and direct response. 0.67. What is the ratio of the Aid flow (current US$) of 1963 in OECD members to that in South Asia?
Make the answer very short. 0.47. What is the ratio of the Aid flow (current US$) in 1960 in OECD members to that in Sub-Saharan Africa (all income levels)?
Give a very brief answer. 10.74. What is the ratio of the Aid flow (current US$) of 1961 in OECD members to that in Sub-Saharan Africa (all income levels)?
Provide a short and direct response. 8.38. What is the ratio of the Aid flow (current US$) of 1962 in OECD members to that in Sub-Saharan Africa (all income levels)?
Provide a short and direct response. 3. What is the ratio of the Aid flow (current US$) in 1963 in OECD members to that in Sub-Saharan Africa (all income levels)?
Give a very brief answer. 3.4. What is the ratio of the Aid flow (current US$) of 1960 in OECD members to that in Sub-Saharan Africa (developing only)?
Offer a terse response. 10.74. What is the ratio of the Aid flow (current US$) of 1961 in OECD members to that in Sub-Saharan Africa (developing only)?
Keep it short and to the point. 8.38. What is the ratio of the Aid flow (current US$) in 1962 in OECD members to that in Sub-Saharan Africa (developing only)?
Your answer should be compact. 3. What is the ratio of the Aid flow (current US$) in 1963 in OECD members to that in Sub-Saharan Africa (developing only)?
Offer a very short reply. 3.4. What is the ratio of the Aid flow (current US$) of 1960 in OECD members to that in Upper middle income?
Make the answer very short. 1.07. What is the ratio of the Aid flow (current US$) of 1961 in OECD members to that in Upper middle income?
Provide a succinct answer. 0.71. What is the ratio of the Aid flow (current US$) of 1962 in OECD members to that in Upper middle income?
Ensure brevity in your answer.  0.72. What is the ratio of the Aid flow (current US$) of 1963 in OECD members to that in Upper middle income?
Keep it short and to the point. 0.81. What is the ratio of the Aid flow (current US$) of 1960 in OECD members to that in World?
Offer a very short reply. 0.16. What is the ratio of the Aid flow (current US$) in 1961 in OECD members to that in World?
Offer a very short reply. 0.2. What is the ratio of the Aid flow (current US$) of 1962 in OECD members to that in World?
Your answer should be very brief. 0.18. What is the ratio of the Aid flow (current US$) in 1963 in OECD members to that in World?
Give a very brief answer. 0.16. What is the ratio of the Aid flow (current US$) of 1960 in South Asia to that in Sub-Saharan Africa (all income levels)?
Give a very brief answer. 20.89. What is the ratio of the Aid flow (current US$) in 1961 in South Asia to that in Sub-Saharan Africa (all income levels)?
Give a very brief answer. 8.51. What is the ratio of the Aid flow (current US$) in 1962 in South Asia to that in Sub-Saharan Africa (all income levels)?
Make the answer very short. 4.49. What is the ratio of the Aid flow (current US$) in 1963 in South Asia to that in Sub-Saharan Africa (all income levels)?
Provide a short and direct response. 7.19. What is the ratio of the Aid flow (current US$) in 1960 in South Asia to that in Sub-Saharan Africa (developing only)?
Provide a short and direct response. 20.89. What is the ratio of the Aid flow (current US$) of 1961 in South Asia to that in Sub-Saharan Africa (developing only)?
Ensure brevity in your answer.  8.51. What is the ratio of the Aid flow (current US$) in 1962 in South Asia to that in Sub-Saharan Africa (developing only)?
Your answer should be very brief. 4.49. What is the ratio of the Aid flow (current US$) of 1963 in South Asia to that in Sub-Saharan Africa (developing only)?
Your answer should be very brief. 7.19. What is the ratio of the Aid flow (current US$) in 1960 in South Asia to that in Upper middle income?
Provide a short and direct response. 2.07. What is the ratio of the Aid flow (current US$) of 1961 in South Asia to that in Upper middle income?
Your response must be concise. 0.72. What is the ratio of the Aid flow (current US$) of 1962 in South Asia to that in Upper middle income?
Offer a very short reply. 1.08. What is the ratio of the Aid flow (current US$) of 1963 in South Asia to that in Upper middle income?
Your answer should be very brief. 1.71. What is the ratio of the Aid flow (current US$) of 1960 in South Asia to that in World?
Provide a short and direct response. 0.31. What is the ratio of the Aid flow (current US$) in 1961 in South Asia to that in World?
Provide a succinct answer. 0.2. What is the ratio of the Aid flow (current US$) in 1962 in South Asia to that in World?
Give a very brief answer. 0.26. What is the ratio of the Aid flow (current US$) in 1963 in South Asia to that in World?
Offer a very short reply. 0.33. What is the ratio of the Aid flow (current US$) of 1963 in Sub-Saharan Africa (all income levels) to that in Sub-Saharan Africa (developing only)?
Offer a terse response. 1. What is the ratio of the Aid flow (current US$) in 1960 in Sub-Saharan Africa (all income levels) to that in Upper middle income?
Give a very brief answer. 0.1. What is the ratio of the Aid flow (current US$) in 1961 in Sub-Saharan Africa (all income levels) to that in Upper middle income?
Your answer should be very brief. 0.08. What is the ratio of the Aid flow (current US$) in 1962 in Sub-Saharan Africa (all income levels) to that in Upper middle income?
Your response must be concise. 0.24. What is the ratio of the Aid flow (current US$) in 1963 in Sub-Saharan Africa (all income levels) to that in Upper middle income?
Provide a succinct answer. 0.24. What is the ratio of the Aid flow (current US$) in 1960 in Sub-Saharan Africa (all income levels) to that in World?
Offer a very short reply. 0.01. What is the ratio of the Aid flow (current US$) in 1961 in Sub-Saharan Africa (all income levels) to that in World?
Provide a short and direct response. 0.02. What is the ratio of the Aid flow (current US$) in 1962 in Sub-Saharan Africa (all income levels) to that in World?
Offer a very short reply. 0.06. What is the ratio of the Aid flow (current US$) of 1963 in Sub-Saharan Africa (all income levels) to that in World?
Your answer should be compact. 0.05. What is the ratio of the Aid flow (current US$) in 1960 in Sub-Saharan Africa (developing only) to that in Upper middle income?
Keep it short and to the point. 0.1. What is the ratio of the Aid flow (current US$) of 1961 in Sub-Saharan Africa (developing only) to that in Upper middle income?
Give a very brief answer. 0.08. What is the ratio of the Aid flow (current US$) in 1962 in Sub-Saharan Africa (developing only) to that in Upper middle income?
Your answer should be very brief. 0.24. What is the ratio of the Aid flow (current US$) in 1963 in Sub-Saharan Africa (developing only) to that in Upper middle income?
Make the answer very short. 0.24. What is the ratio of the Aid flow (current US$) in 1960 in Sub-Saharan Africa (developing only) to that in World?
Provide a short and direct response. 0.01. What is the ratio of the Aid flow (current US$) in 1961 in Sub-Saharan Africa (developing only) to that in World?
Provide a short and direct response. 0.02. What is the ratio of the Aid flow (current US$) in 1962 in Sub-Saharan Africa (developing only) to that in World?
Your answer should be very brief. 0.06. What is the ratio of the Aid flow (current US$) of 1963 in Sub-Saharan Africa (developing only) to that in World?
Provide a short and direct response. 0.05. What is the ratio of the Aid flow (current US$) of 1960 in Upper middle income to that in World?
Offer a very short reply. 0.15. What is the ratio of the Aid flow (current US$) of 1961 in Upper middle income to that in World?
Provide a short and direct response. 0.28. What is the ratio of the Aid flow (current US$) of 1962 in Upper middle income to that in World?
Provide a succinct answer. 0.24. What is the ratio of the Aid flow (current US$) of 1963 in Upper middle income to that in World?
Your answer should be very brief. 0.19. What is the difference between the highest and the second highest Aid flow (current US$) in 1960?
Ensure brevity in your answer.  1.79e+09. What is the difference between the highest and the second highest Aid flow (current US$) of 1961?
Provide a short and direct response. 2.32e+09. What is the difference between the highest and the second highest Aid flow (current US$) in 1962?
Offer a terse response. 2.50e+09. What is the difference between the highest and the second highest Aid flow (current US$) in 1963?
Provide a short and direct response. 2.38e+09. What is the difference between the highest and the lowest Aid flow (current US$) of 1960?
Ensure brevity in your answer.  2.54e+09. What is the difference between the highest and the lowest Aid flow (current US$) of 1961?
Your answer should be very brief. 3.15e+09. What is the difference between the highest and the lowest Aid flow (current US$) in 1962?
Offer a very short reply. 3.20e+09. What is the difference between the highest and the lowest Aid flow (current US$) in 1963?
Ensure brevity in your answer.  3.39e+09. 